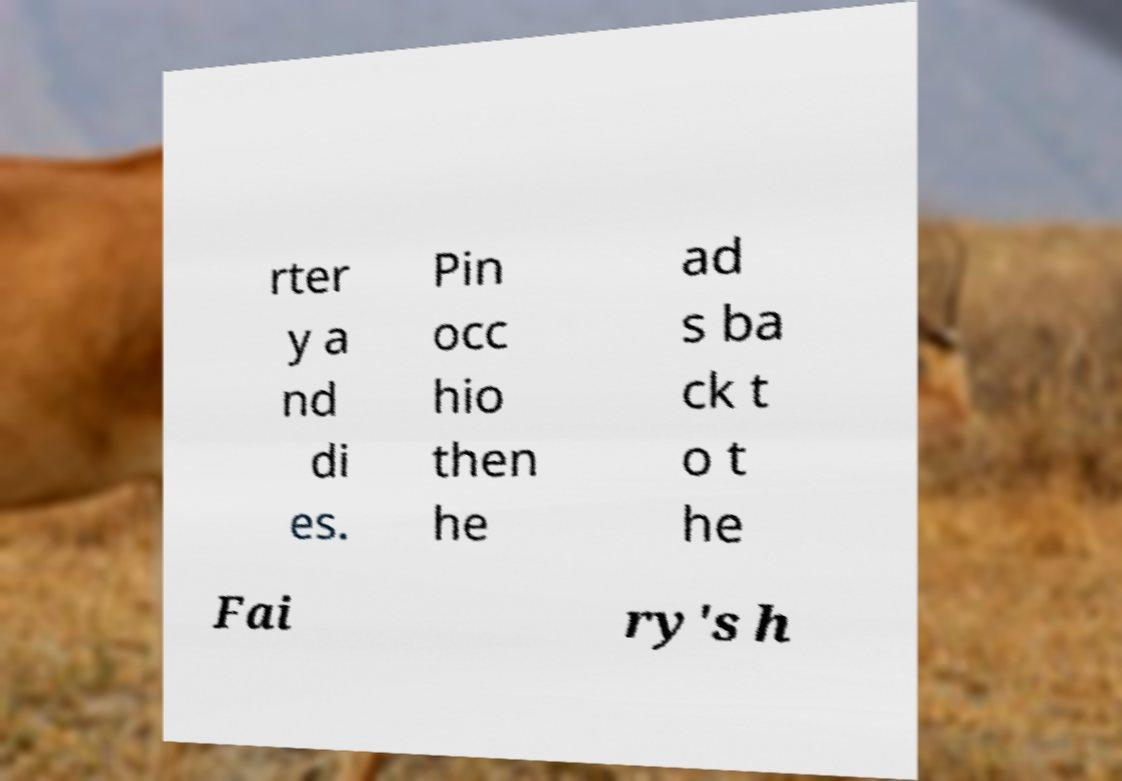For documentation purposes, I need the text within this image transcribed. Could you provide that? rter y a nd di es. Pin occ hio then he ad s ba ck t o t he Fai ry's h 